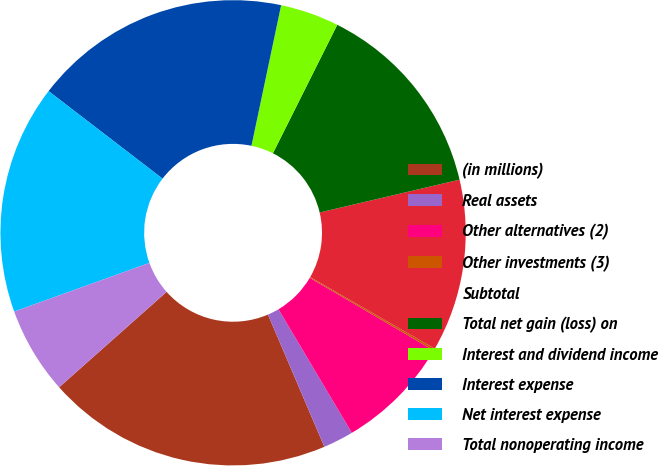Convert chart. <chart><loc_0><loc_0><loc_500><loc_500><pie_chart><fcel>(in millions)<fcel>Real assets<fcel>Other alternatives (2)<fcel>Other investments (3)<fcel>Subtotal<fcel>Total net gain (loss) on<fcel>Interest and dividend income<fcel>Interest expense<fcel>Net interest expense<fcel>Total nonoperating income<nl><fcel>19.86%<fcel>2.11%<fcel>8.03%<fcel>0.14%<fcel>11.97%<fcel>13.94%<fcel>4.08%<fcel>17.89%<fcel>15.92%<fcel>6.06%<nl></chart> 